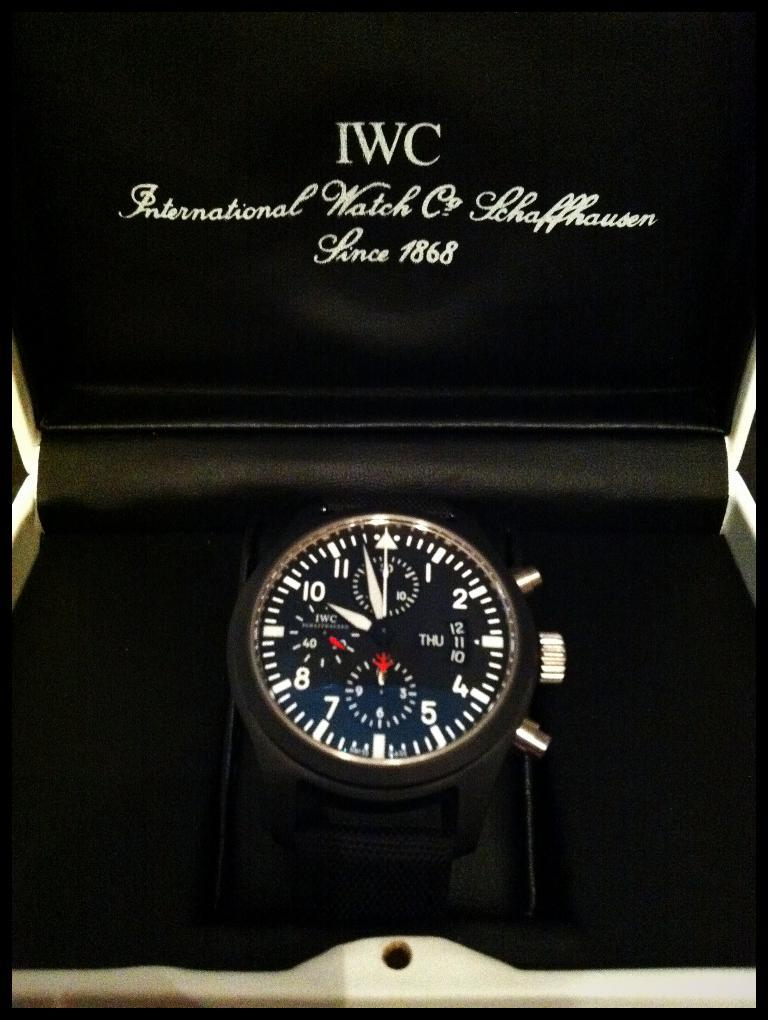<image>
Give a short and clear explanation of the subsequent image. An IWC watch on display in a black lined box. 